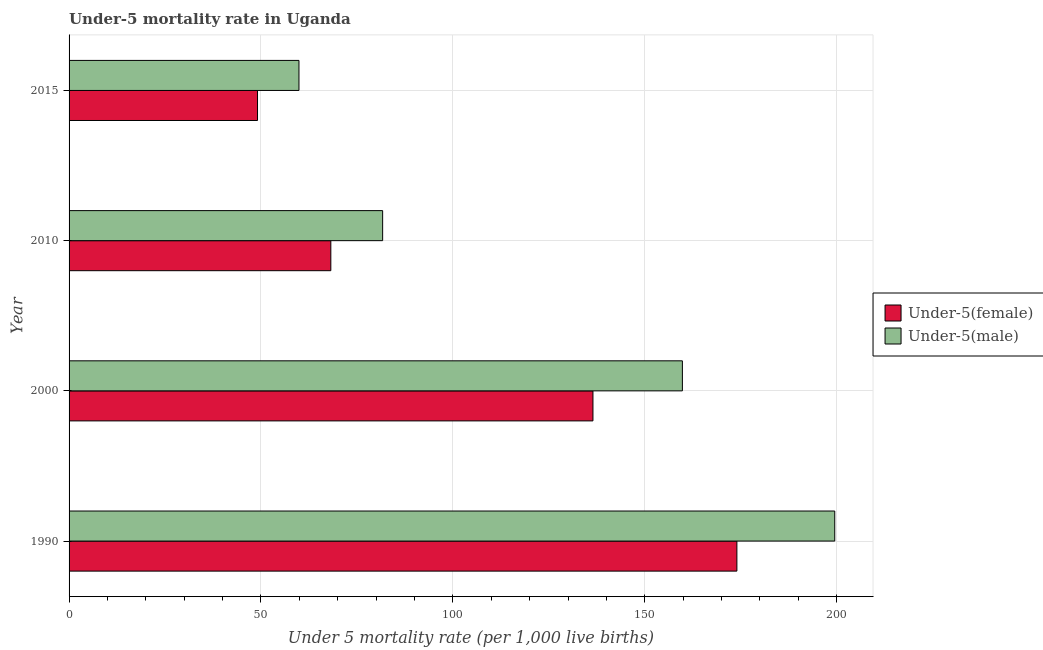What is the under-5 male mortality rate in 1990?
Your answer should be compact. 199.5. Across all years, what is the maximum under-5 female mortality rate?
Provide a succinct answer. 174. Across all years, what is the minimum under-5 female mortality rate?
Provide a short and direct response. 49.1. In which year was the under-5 male mortality rate maximum?
Ensure brevity in your answer.  1990. In which year was the under-5 male mortality rate minimum?
Provide a short and direct response. 2015. What is the total under-5 male mortality rate in the graph?
Keep it short and to the point. 500.9. What is the difference between the under-5 male mortality rate in 2000 and that in 2010?
Provide a short and direct response. 78.1. What is the difference between the under-5 male mortality rate in 1990 and the under-5 female mortality rate in 2015?
Ensure brevity in your answer.  150.4. What is the average under-5 male mortality rate per year?
Provide a short and direct response. 125.22. In the year 1990, what is the difference between the under-5 female mortality rate and under-5 male mortality rate?
Your response must be concise. -25.5. What is the ratio of the under-5 female mortality rate in 2000 to that in 2010?
Give a very brief answer. 2. Is the under-5 male mortality rate in 1990 less than that in 2000?
Ensure brevity in your answer.  No. Is the difference between the under-5 male mortality rate in 2000 and 2010 greater than the difference between the under-5 female mortality rate in 2000 and 2010?
Your response must be concise. Yes. What is the difference between the highest and the second highest under-5 male mortality rate?
Your answer should be very brief. 39.7. What is the difference between the highest and the lowest under-5 female mortality rate?
Your answer should be very brief. 124.9. In how many years, is the under-5 female mortality rate greater than the average under-5 female mortality rate taken over all years?
Keep it short and to the point. 2. What does the 1st bar from the top in 2000 represents?
Your answer should be very brief. Under-5(male). What does the 2nd bar from the bottom in 2010 represents?
Your answer should be very brief. Under-5(male). How many bars are there?
Offer a very short reply. 8. What is the difference between two consecutive major ticks on the X-axis?
Give a very brief answer. 50. Does the graph contain any zero values?
Keep it short and to the point. No. Where does the legend appear in the graph?
Your response must be concise. Center right. How are the legend labels stacked?
Offer a terse response. Vertical. What is the title of the graph?
Make the answer very short. Under-5 mortality rate in Uganda. What is the label or title of the X-axis?
Keep it short and to the point. Under 5 mortality rate (per 1,0 live births). What is the label or title of the Y-axis?
Keep it short and to the point. Year. What is the Under 5 mortality rate (per 1,000 live births) in Under-5(female) in 1990?
Provide a succinct answer. 174. What is the Under 5 mortality rate (per 1,000 live births) in Under-5(male) in 1990?
Keep it short and to the point. 199.5. What is the Under 5 mortality rate (per 1,000 live births) of Under-5(female) in 2000?
Ensure brevity in your answer.  136.5. What is the Under 5 mortality rate (per 1,000 live births) of Under-5(male) in 2000?
Offer a very short reply. 159.8. What is the Under 5 mortality rate (per 1,000 live births) in Under-5(female) in 2010?
Offer a terse response. 68.2. What is the Under 5 mortality rate (per 1,000 live births) in Under-5(male) in 2010?
Provide a short and direct response. 81.7. What is the Under 5 mortality rate (per 1,000 live births) of Under-5(female) in 2015?
Offer a terse response. 49.1. What is the Under 5 mortality rate (per 1,000 live births) in Under-5(male) in 2015?
Provide a succinct answer. 59.9. Across all years, what is the maximum Under 5 mortality rate (per 1,000 live births) in Under-5(female)?
Keep it short and to the point. 174. Across all years, what is the maximum Under 5 mortality rate (per 1,000 live births) in Under-5(male)?
Provide a succinct answer. 199.5. Across all years, what is the minimum Under 5 mortality rate (per 1,000 live births) in Under-5(female)?
Provide a succinct answer. 49.1. Across all years, what is the minimum Under 5 mortality rate (per 1,000 live births) of Under-5(male)?
Your answer should be very brief. 59.9. What is the total Under 5 mortality rate (per 1,000 live births) in Under-5(female) in the graph?
Provide a succinct answer. 427.8. What is the total Under 5 mortality rate (per 1,000 live births) in Under-5(male) in the graph?
Your response must be concise. 500.9. What is the difference between the Under 5 mortality rate (per 1,000 live births) in Under-5(female) in 1990 and that in 2000?
Your answer should be very brief. 37.5. What is the difference between the Under 5 mortality rate (per 1,000 live births) of Under-5(male) in 1990 and that in 2000?
Offer a terse response. 39.7. What is the difference between the Under 5 mortality rate (per 1,000 live births) of Under-5(female) in 1990 and that in 2010?
Your answer should be compact. 105.8. What is the difference between the Under 5 mortality rate (per 1,000 live births) in Under-5(male) in 1990 and that in 2010?
Keep it short and to the point. 117.8. What is the difference between the Under 5 mortality rate (per 1,000 live births) in Under-5(female) in 1990 and that in 2015?
Your answer should be very brief. 124.9. What is the difference between the Under 5 mortality rate (per 1,000 live births) of Under-5(male) in 1990 and that in 2015?
Give a very brief answer. 139.6. What is the difference between the Under 5 mortality rate (per 1,000 live births) in Under-5(female) in 2000 and that in 2010?
Your response must be concise. 68.3. What is the difference between the Under 5 mortality rate (per 1,000 live births) in Under-5(male) in 2000 and that in 2010?
Your answer should be compact. 78.1. What is the difference between the Under 5 mortality rate (per 1,000 live births) of Under-5(female) in 2000 and that in 2015?
Provide a short and direct response. 87.4. What is the difference between the Under 5 mortality rate (per 1,000 live births) in Under-5(male) in 2000 and that in 2015?
Give a very brief answer. 99.9. What is the difference between the Under 5 mortality rate (per 1,000 live births) in Under-5(male) in 2010 and that in 2015?
Your response must be concise. 21.8. What is the difference between the Under 5 mortality rate (per 1,000 live births) of Under-5(female) in 1990 and the Under 5 mortality rate (per 1,000 live births) of Under-5(male) in 2000?
Provide a succinct answer. 14.2. What is the difference between the Under 5 mortality rate (per 1,000 live births) of Under-5(female) in 1990 and the Under 5 mortality rate (per 1,000 live births) of Under-5(male) in 2010?
Your answer should be compact. 92.3. What is the difference between the Under 5 mortality rate (per 1,000 live births) in Under-5(female) in 1990 and the Under 5 mortality rate (per 1,000 live births) in Under-5(male) in 2015?
Make the answer very short. 114.1. What is the difference between the Under 5 mortality rate (per 1,000 live births) of Under-5(female) in 2000 and the Under 5 mortality rate (per 1,000 live births) of Under-5(male) in 2010?
Offer a terse response. 54.8. What is the difference between the Under 5 mortality rate (per 1,000 live births) in Under-5(female) in 2000 and the Under 5 mortality rate (per 1,000 live births) in Under-5(male) in 2015?
Provide a succinct answer. 76.6. What is the average Under 5 mortality rate (per 1,000 live births) of Under-5(female) per year?
Give a very brief answer. 106.95. What is the average Under 5 mortality rate (per 1,000 live births) of Under-5(male) per year?
Your answer should be very brief. 125.22. In the year 1990, what is the difference between the Under 5 mortality rate (per 1,000 live births) in Under-5(female) and Under 5 mortality rate (per 1,000 live births) in Under-5(male)?
Offer a very short reply. -25.5. In the year 2000, what is the difference between the Under 5 mortality rate (per 1,000 live births) in Under-5(female) and Under 5 mortality rate (per 1,000 live births) in Under-5(male)?
Make the answer very short. -23.3. What is the ratio of the Under 5 mortality rate (per 1,000 live births) in Under-5(female) in 1990 to that in 2000?
Keep it short and to the point. 1.27. What is the ratio of the Under 5 mortality rate (per 1,000 live births) of Under-5(male) in 1990 to that in 2000?
Your answer should be compact. 1.25. What is the ratio of the Under 5 mortality rate (per 1,000 live births) in Under-5(female) in 1990 to that in 2010?
Provide a succinct answer. 2.55. What is the ratio of the Under 5 mortality rate (per 1,000 live births) in Under-5(male) in 1990 to that in 2010?
Provide a short and direct response. 2.44. What is the ratio of the Under 5 mortality rate (per 1,000 live births) of Under-5(female) in 1990 to that in 2015?
Your answer should be compact. 3.54. What is the ratio of the Under 5 mortality rate (per 1,000 live births) of Under-5(male) in 1990 to that in 2015?
Your answer should be compact. 3.33. What is the ratio of the Under 5 mortality rate (per 1,000 live births) of Under-5(female) in 2000 to that in 2010?
Keep it short and to the point. 2. What is the ratio of the Under 5 mortality rate (per 1,000 live births) of Under-5(male) in 2000 to that in 2010?
Your response must be concise. 1.96. What is the ratio of the Under 5 mortality rate (per 1,000 live births) of Under-5(female) in 2000 to that in 2015?
Give a very brief answer. 2.78. What is the ratio of the Under 5 mortality rate (per 1,000 live births) of Under-5(male) in 2000 to that in 2015?
Provide a succinct answer. 2.67. What is the ratio of the Under 5 mortality rate (per 1,000 live births) of Under-5(female) in 2010 to that in 2015?
Offer a very short reply. 1.39. What is the ratio of the Under 5 mortality rate (per 1,000 live births) of Under-5(male) in 2010 to that in 2015?
Keep it short and to the point. 1.36. What is the difference between the highest and the second highest Under 5 mortality rate (per 1,000 live births) in Under-5(female)?
Offer a terse response. 37.5. What is the difference between the highest and the second highest Under 5 mortality rate (per 1,000 live births) of Under-5(male)?
Provide a succinct answer. 39.7. What is the difference between the highest and the lowest Under 5 mortality rate (per 1,000 live births) of Under-5(female)?
Make the answer very short. 124.9. What is the difference between the highest and the lowest Under 5 mortality rate (per 1,000 live births) of Under-5(male)?
Offer a very short reply. 139.6. 